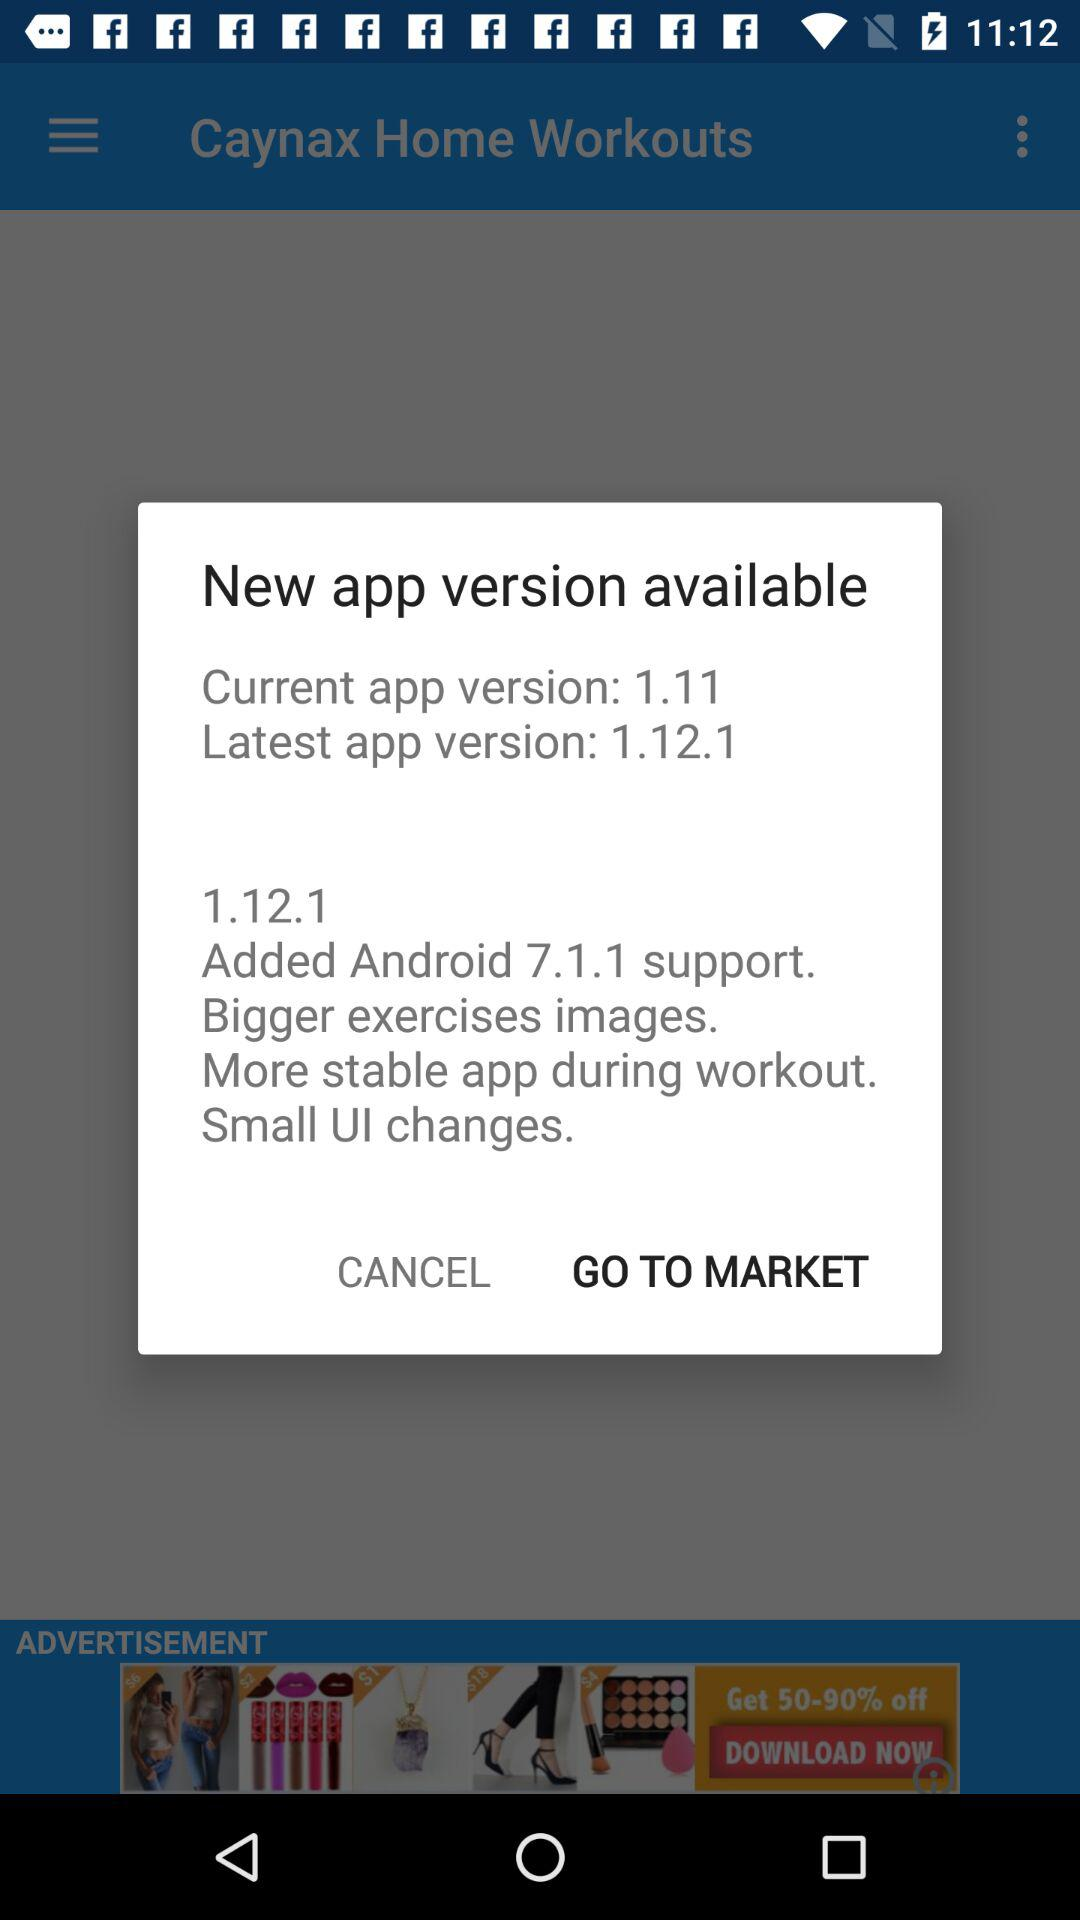How many versions of the app are available?
Answer the question using a single word or phrase. 2 